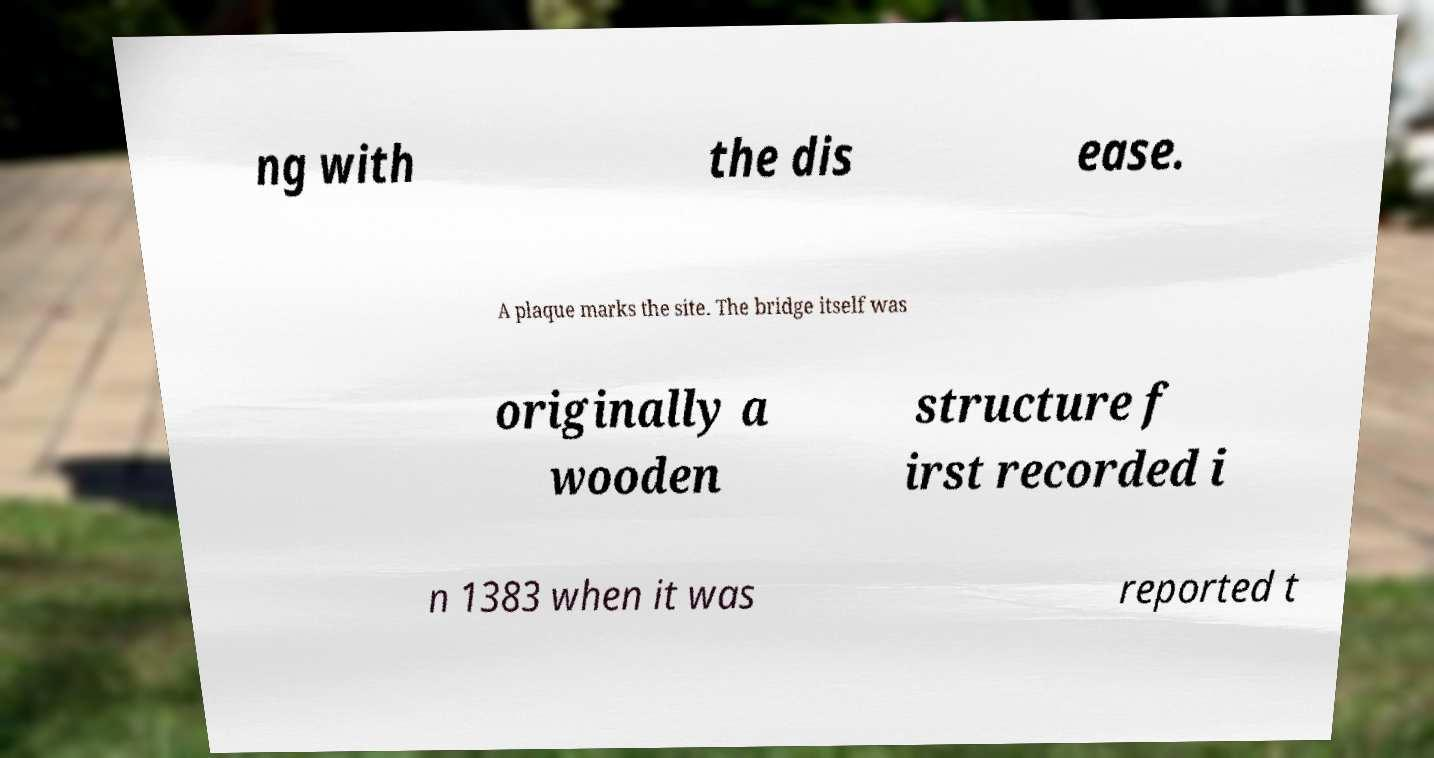For documentation purposes, I need the text within this image transcribed. Could you provide that? ng with the dis ease. A plaque marks the site. The bridge itself was originally a wooden structure f irst recorded i n 1383 when it was reported t 